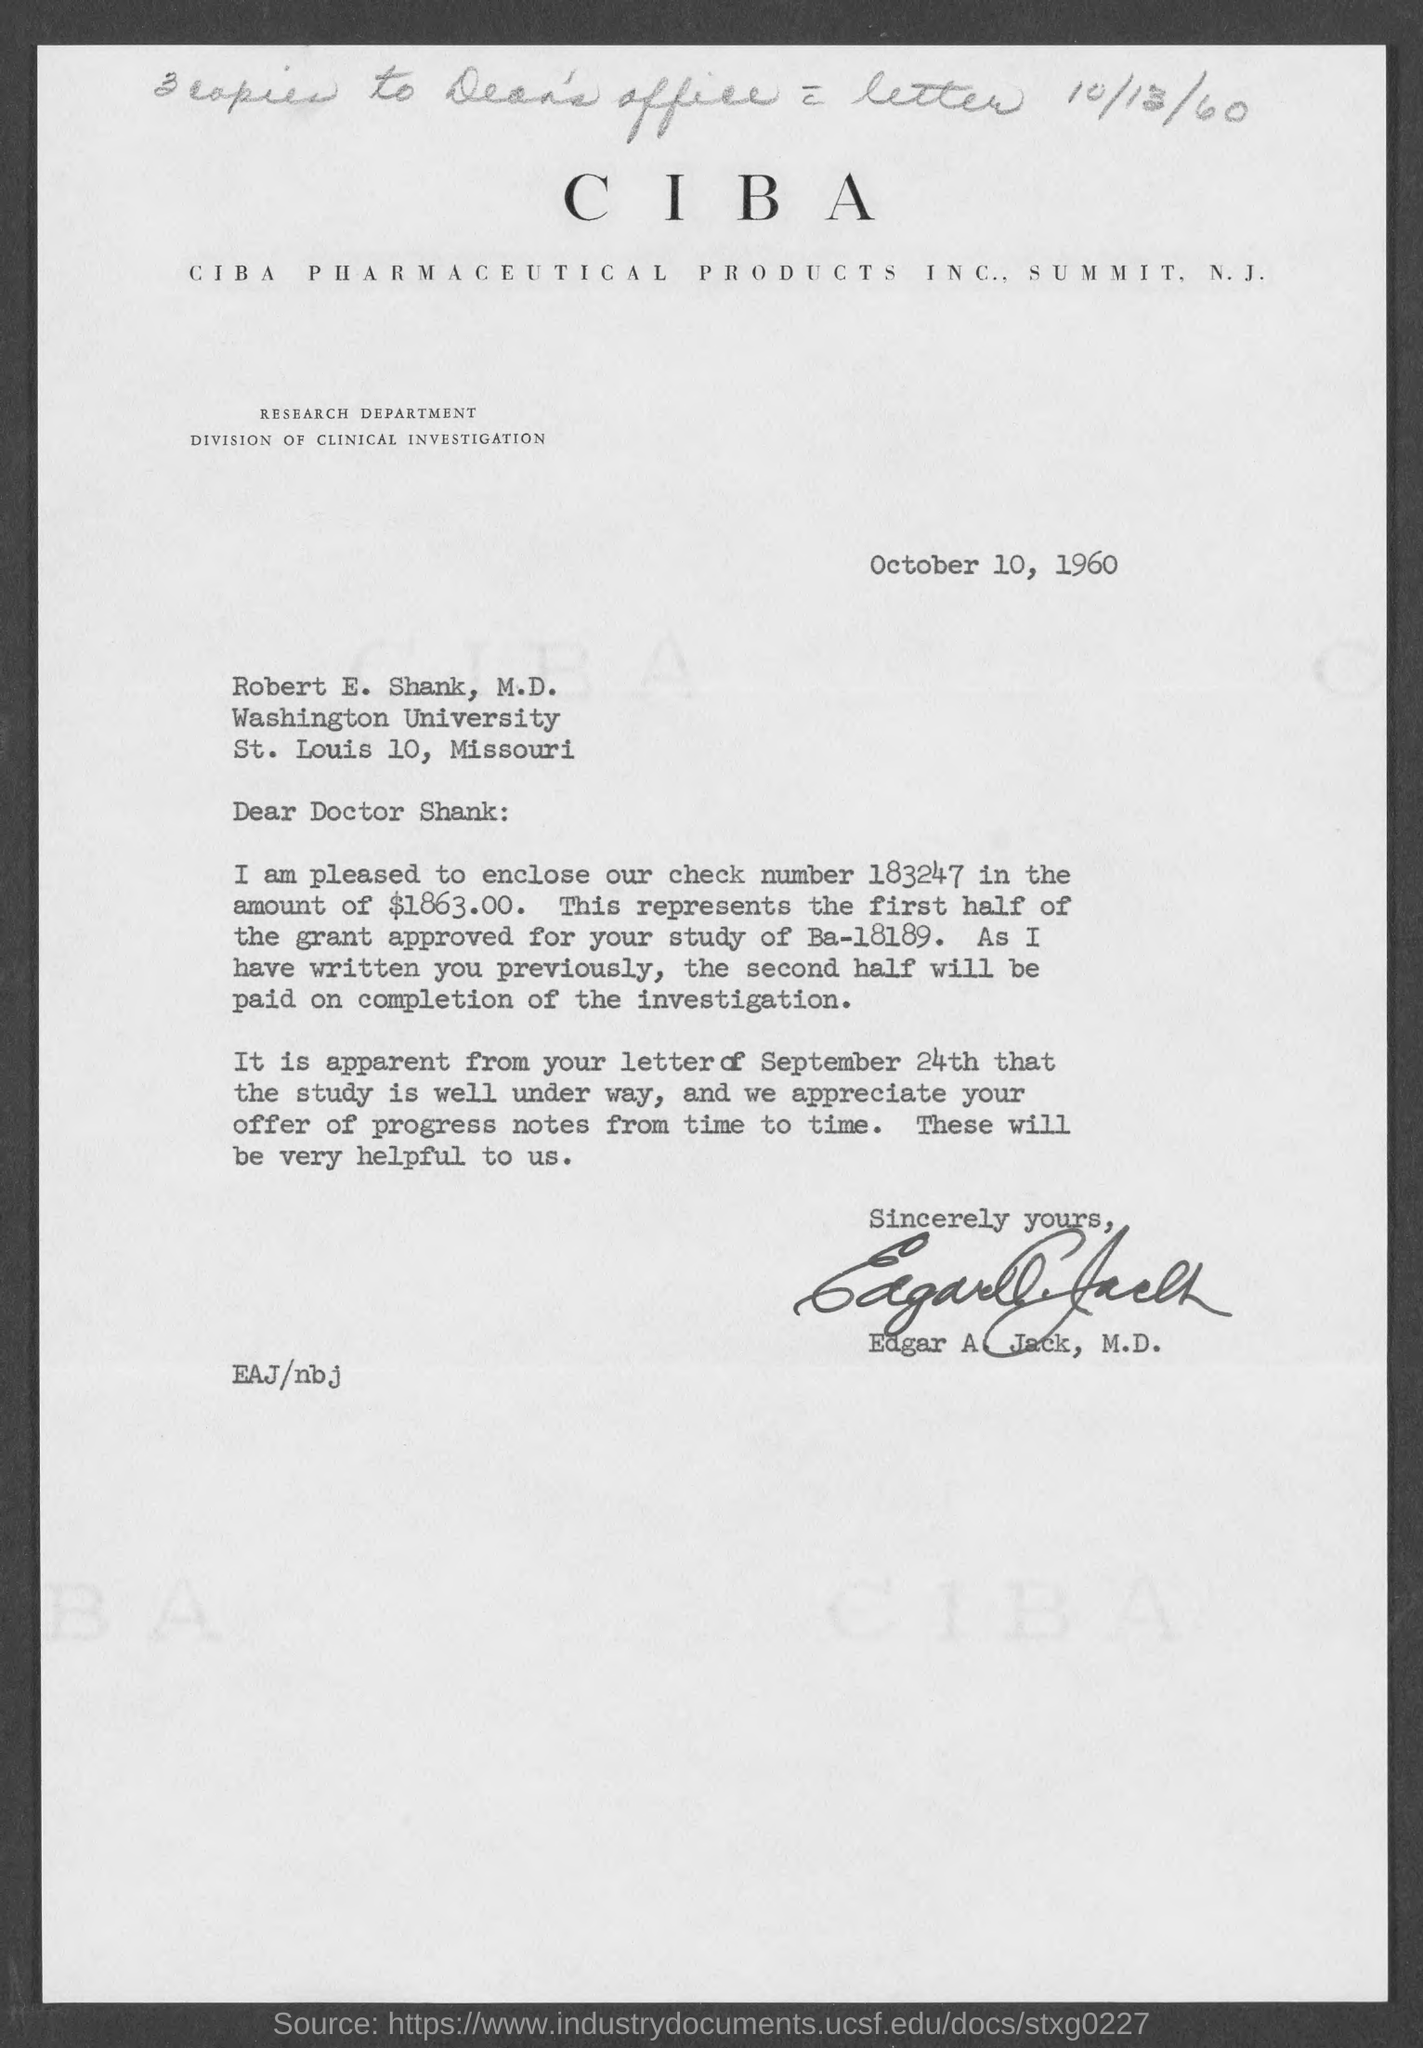How many copies to Dean's Office?
Ensure brevity in your answer.  3. When is the document dated?
Your answer should be compact. October 10, 1960. To whom is the letter addressed?
Keep it short and to the point. Robert E. Shank, M.D. What is the check number mentioned?
Your response must be concise. 183247. What is the amount in the check number 183247?
Your response must be concise. $1863.00. When will the second half be paid?
Keep it short and to the point. On completion of the investigation. Who has signed the letter?
Provide a succinct answer. Edgar A. Jack, M.D. 